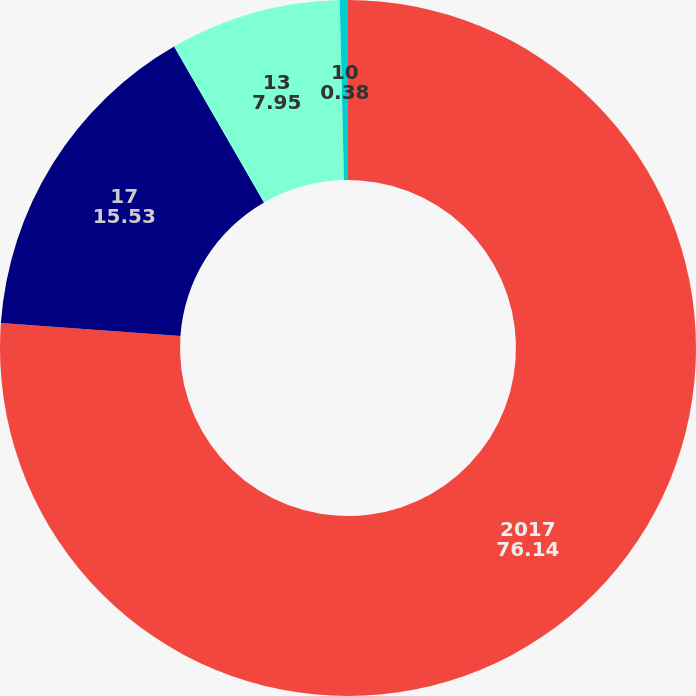<chart> <loc_0><loc_0><loc_500><loc_500><pie_chart><fcel>2017<fcel>17<fcel>13<fcel>10<nl><fcel>76.14%<fcel>15.53%<fcel>7.95%<fcel>0.38%<nl></chart> 